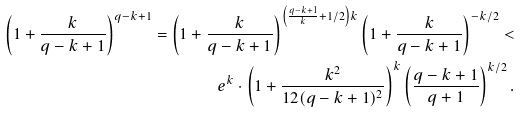Convert formula to latex. <formula><loc_0><loc_0><loc_500><loc_500>\left ( 1 + \frac { k } { q - k + 1 } \right ) ^ { q - k + 1 } = \left ( 1 + \frac { k } { q - k + 1 } \right ) ^ { \left ( \frac { q - k + 1 } { k } + 1 / 2 \right ) k } \left ( 1 + \frac { k } { q - k + 1 } \right ) ^ { - k / 2 } < \\ e ^ { k } \cdot \left ( 1 + \frac { k ^ { 2 } } { 1 2 ( q - k + 1 ) ^ { 2 } } \right ) ^ { k } \left ( \frac { q - k + 1 } { q + 1 } \right ) ^ { k / 2 } .</formula> 